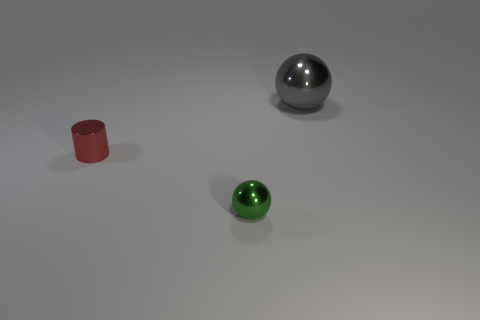Add 1 blue cylinders. How many objects exist? 4 Subtract all cylinders. How many objects are left? 2 Add 2 cylinders. How many cylinders are left? 3 Add 2 green things. How many green things exist? 3 Subtract 0 brown balls. How many objects are left? 3 Subtract all spheres. Subtract all yellow things. How many objects are left? 1 